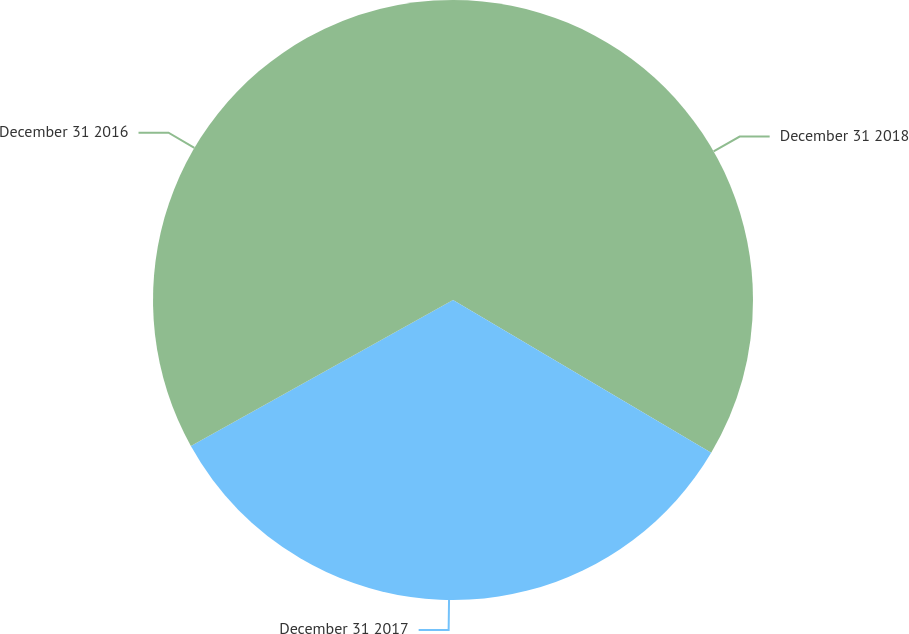<chart> <loc_0><loc_0><loc_500><loc_500><pie_chart><fcel>December 31 2018<fcel>December 31 2017<fcel>December 31 2016<nl><fcel>33.5%<fcel>33.41%<fcel>33.08%<nl></chart> 